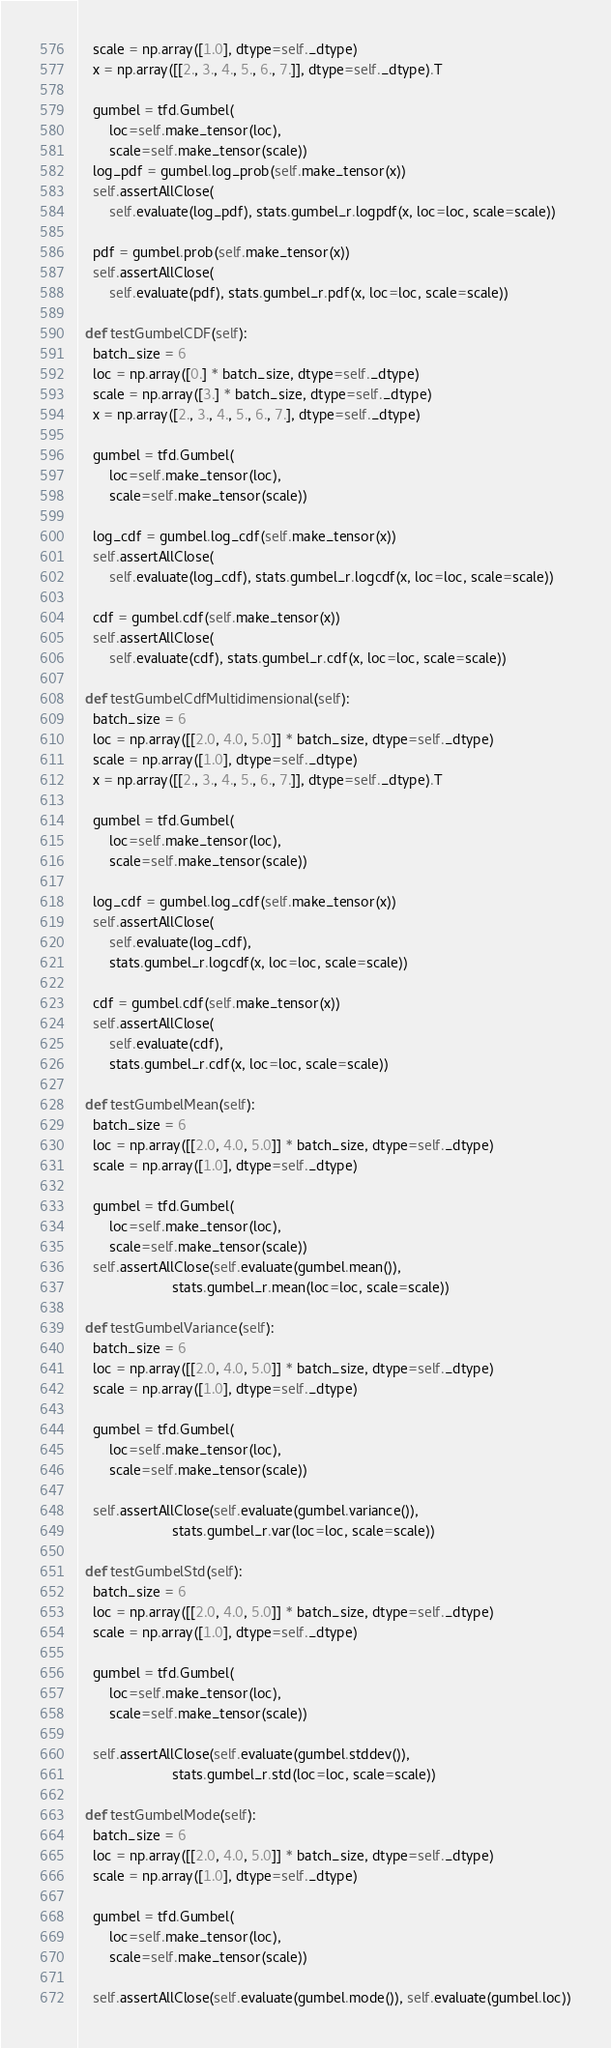Convert code to text. <code><loc_0><loc_0><loc_500><loc_500><_Python_>    scale = np.array([1.0], dtype=self._dtype)
    x = np.array([[2., 3., 4., 5., 6., 7.]], dtype=self._dtype).T

    gumbel = tfd.Gumbel(
        loc=self.make_tensor(loc),
        scale=self.make_tensor(scale))
    log_pdf = gumbel.log_prob(self.make_tensor(x))
    self.assertAllClose(
        self.evaluate(log_pdf), stats.gumbel_r.logpdf(x, loc=loc, scale=scale))

    pdf = gumbel.prob(self.make_tensor(x))
    self.assertAllClose(
        self.evaluate(pdf), stats.gumbel_r.pdf(x, loc=loc, scale=scale))

  def testGumbelCDF(self):
    batch_size = 6
    loc = np.array([0.] * batch_size, dtype=self._dtype)
    scale = np.array([3.] * batch_size, dtype=self._dtype)
    x = np.array([2., 3., 4., 5., 6., 7.], dtype=self._dtype)

    gumbel = tfd.Gumbel(
        loc=self.make_tensor(loc),
        scale=self.make_tensor(scale))

    log_cdf = gumbel.log_cdf(self.make_tensor(x))
    self.assertAllClose(
        self.evaluate(log_cdf), stats.gumbel_r.logcdf(x, loc=loc, scale=scale))

    cdf = gumbel.cdf(self.make_tensor(x))
    self.assertAllClose(
        self.evaluate(cdf), stats.gumbel_r.cdf(x, loc=loc, scale=scale))

  def testGumbelCdfMultidimensional(self):
    batch_size = 6
    loc = np.array([[2.0, 4.0, 5.0]] * batch_size, dtype=self._dtype)
    scale = np.array([1.0], dtype=self._dtype)
    x = np.array([[2., 3., 4., 5., 6., 7.]], dtype=self._dtype).T

    gumbel = tfd.Gumbel(
        loc=self.make_tensor(loc),
        scale=self.make_tensor(scale))

    log_cdf = gumbel.log_cdf(self.make_tensor(x))
    self.assertAllClose(
        self.evaluate(log_cdf),
        stats.gumbel_r.logcdf(x, loc=loc, scale=scale))

    cdf = gumbel.cdf(self.make_tensor(x))
    self.assertAllClose(
        self.evaluate(cdf),
        stats.gumbel_r.cdf(x, loc=loc, scale=scale))

  def testGumbelMean(self):
    batch_size = 6
    loc = np.array([[2.0, 4.0, 5.0]] * batch_size, dtype=self._dtype)
    scale = np.array([1.0], dtype=self._dtype)

    gumbel = tfd.Gumbel(
        loc=self.make_tensor(loc),
        scale=self.make_tensor(scale))
    self.assertAllClose(self.evaluate(gumbel.mean()),
                        stats.gumbel_r.mean(loc=loc, scale=scale))

  def testGumbelVariance(self):
    batch_size = 6
    loc = np.array([[2.0, 4.0, 5.0]] * batch_size, dtype=self._dtype)
    scale = np.array([1.0], dtype=self._dtype)

    gumbel = tfd.Gumbel(
        loc=self.make_tensor(loc),
        scale=self.make_tensor(scale))

    self.assertAllClose(self.evaluate(gumbel.variance()),
                        stats.gumbel_r.var(loc=loc, scale=scale))

  def testGumbelStd(self):
    batch_size = 6
    loc = np.array([[2.0, 4.0, 5.0]] * batch_size, dtype=self._dtype)
    scale = np.array([1.0], dtype=self._dtype)

    gumbel = tfd.Gumbel(
        loc=self.make_tensor(loc),
        scale=self.make_tensor(scale))

    self.assertAllClose(self.evaluate(gumbel.stddev()),
                        stats.gumbel_r.std(loc=loc, scale=scale))

  def testGumbelMode(self):
    batch_size = 6
    loc = np.array([[2.0, 4.0, 5.0]] * batch_size, dtype=self._dtype)
    scale = np.array([1.0], dtype=self._dtype)

    gumbel = tfd.Gumbel(
        loc=self.make_tensor(loc),
        scale=self.make_tensor(scale))

    self.assertAllClose(self.evaluate(gumbel.mode()), self.evaluate(gumbel.loc))
</code> 